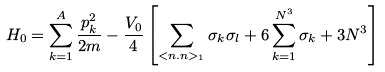Convert formula to latex. <formula><loc_0><loc_0><loc_500><loc_500>H _ { 0 } = \sum _ { k = 1 } ^ { A } \frac { p _ { k } ^ { 2 } } { 2 m } - \frac { V _ { 0 } } { 4 } \left [ \sum _ { < n . n > _ { 1 } } \sigma _ { k } \sigma _ { l } + 6 \sum _ { k = 1 } ^ { N ^ { 3 } } \sigma _ { k } + 3 N ^ { 3 } \right ]</formula> 